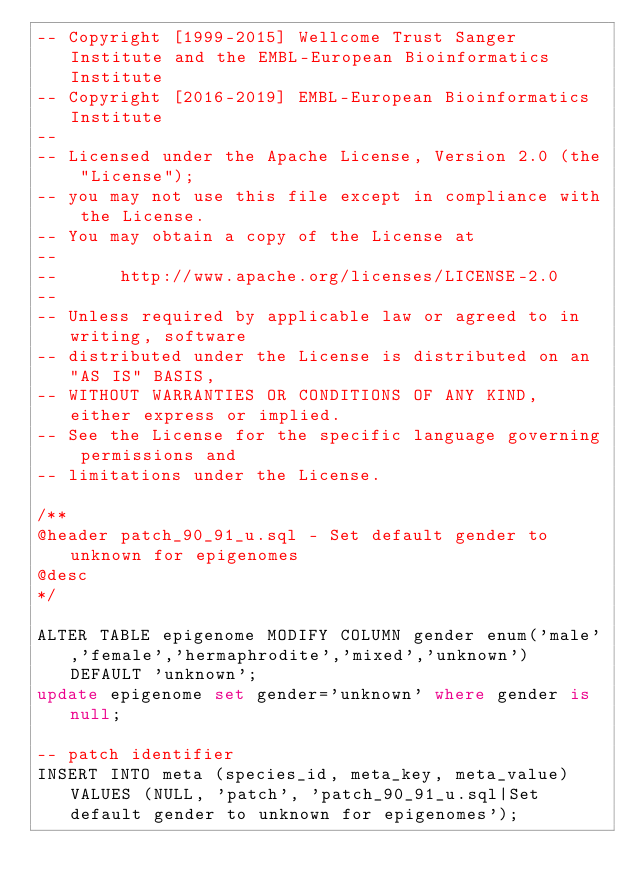<code> <loc_0><loc_0><loc_500><loc_500><_SQL_>-- Copyright [1999-2015] Wellcome Trust Sanger Institute and the EMBL-European Bioinformatics Institute
-- Copyright [2016-2019] EMBL-European Bioinformatics Institute
--
-- Licensed under the Apache License, Version 2.0 (the "License");
-- you may not use this file except in compliance with the License.
-- You may obtain a copy of the License at
--
--      http://www.apache.org/licenses/LICENSE-2.0
--
-- Unless required by applicable law or agreed to in writing, software
-- distributed under the License is distributed on an "AS IS" BASIS,
-- WITHOUT WARRANTIES OR CONDITIONS OF ANY KIND, either express or implied.
-- See the License for the specific language governing permissions and
-- limitations under the License.

/**
@header patch_90_91_u.sql - Set default gender to unknown for epigenomes
@desc   
*/

ALTER TABLE epigenome MODIFY COLUMN gender enum('male','female','hermaphrodite','mixed','unknown') DEFAULT 'unknown';
update epigenome set gender='unknown' where gender is null;

-- patch identifier
INSERT INTO meta (species_id, meta_key, meta_value) VALUES (NULL, 'patch', 'patch_90_91_u.sql|Set default gender to unknown for epigenomes');
</code> 